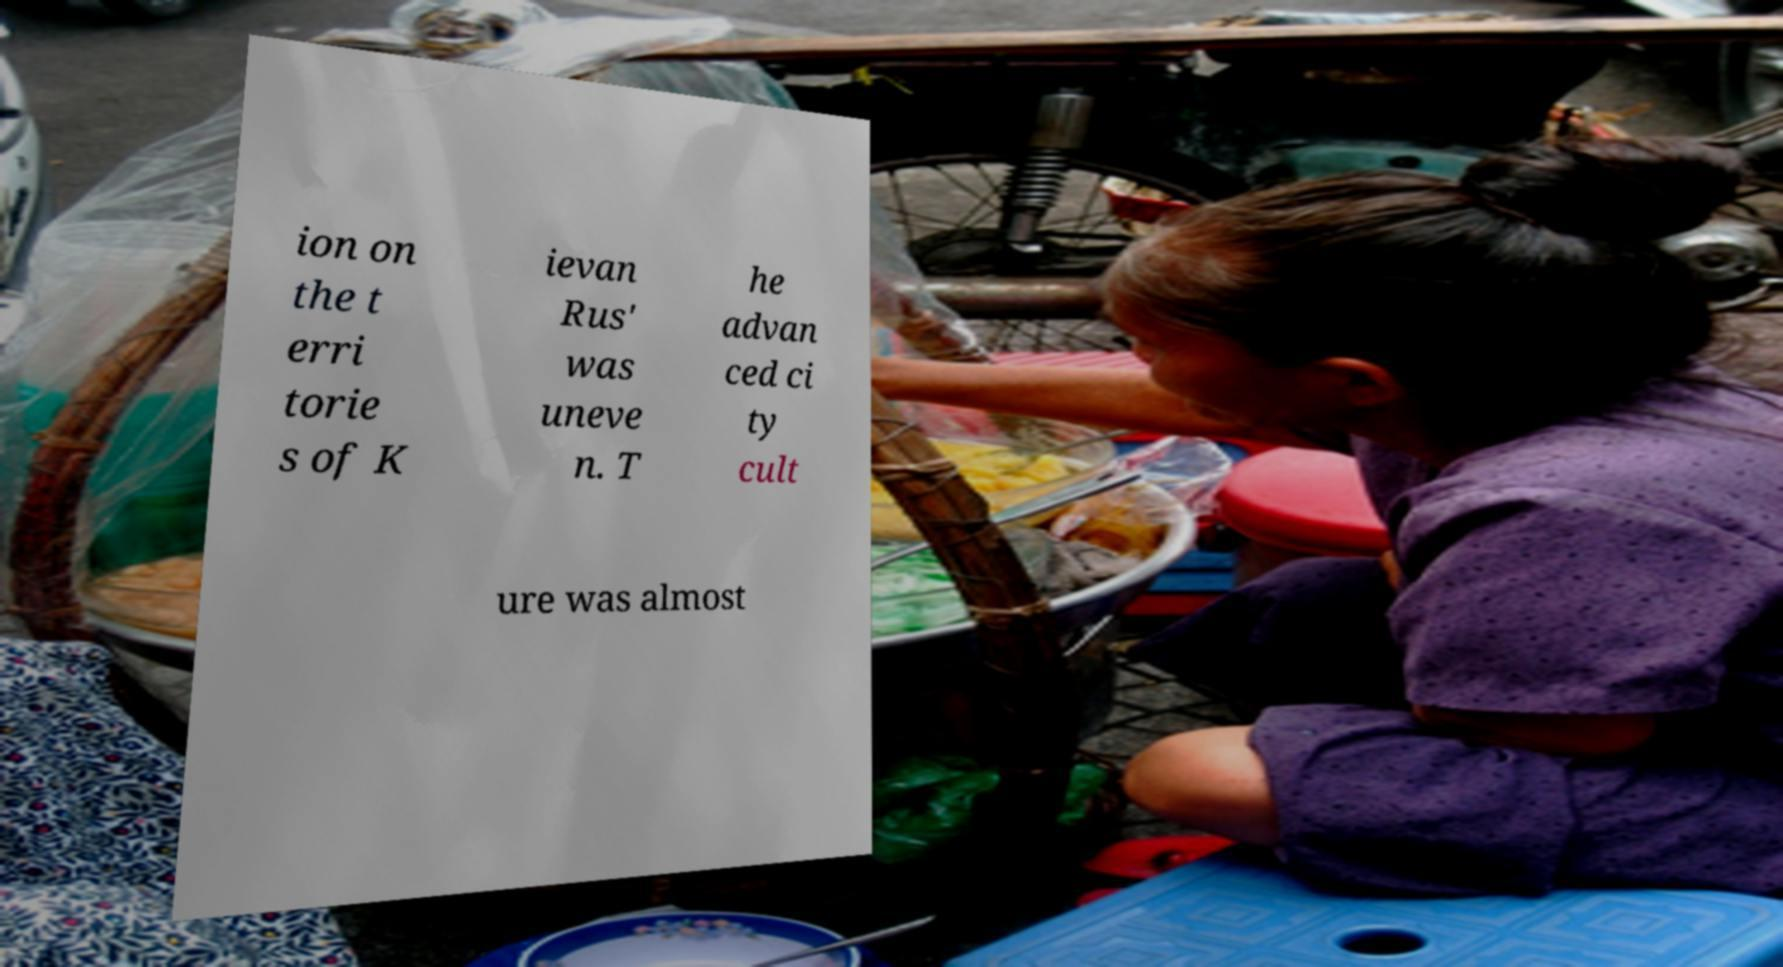There's text embedded in this image that I need extracted. Can you transcribe it verbatim? ion on the t erri torie s of K ievan Rus' was uneve n. T he advan ced ci ty cult ure was almost 